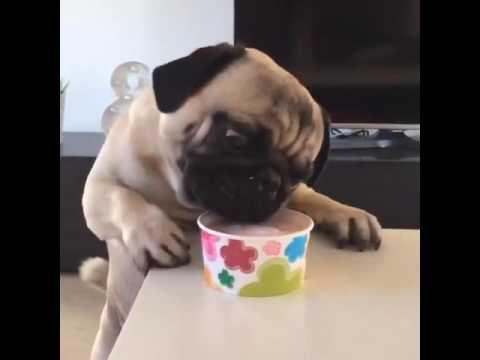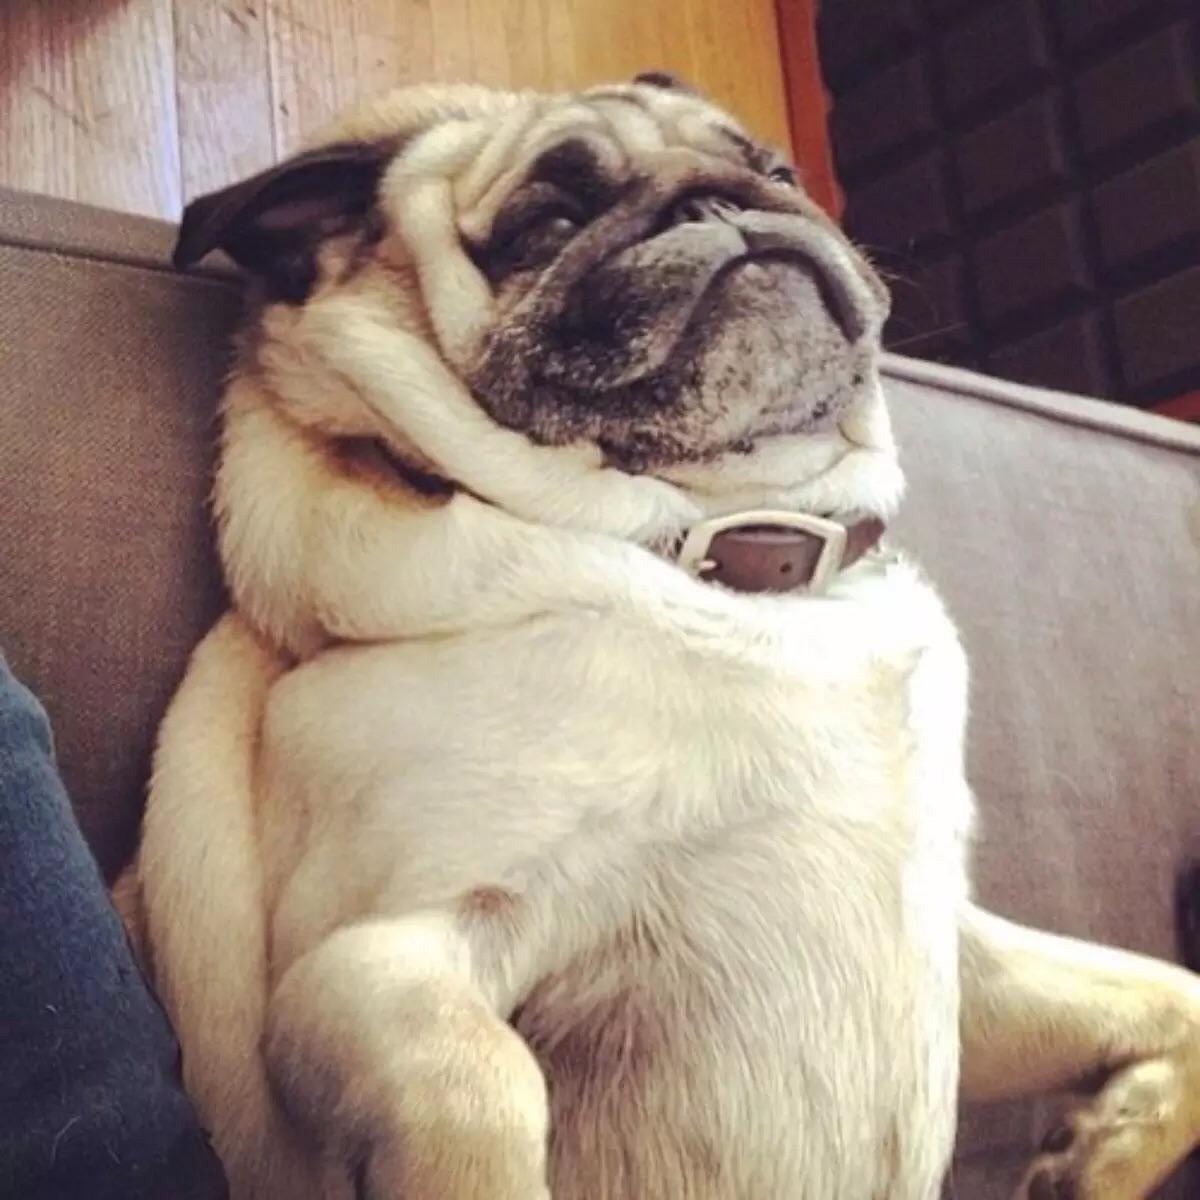The first image is the image on the left, the second image is the image on the right. Given the left and right images, does the statement "There is a dog that is not eating anything." hold true? Answer yes or no. Yes. The first image is the image on the left, the second image is the image on the right. Evaluate the accuracy of this statement regarding the images: "At least 2 dogs are being fed ice cream in a waffle cone that a person is holding.". Is it true? Answer yes or no. No. 